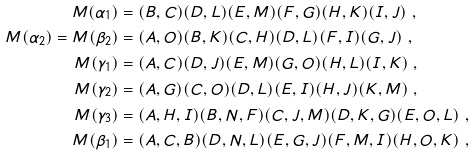Convert formula to latex. <formula><loc_0><loc_0><loc_500><loc_500>M ( \alpha _ { 1 } ) & = ( B , C ) ( D , L ) ( E , M ) ( F , G ) ( H , K ) ( I , J ) \ , \\ M ( \alpha _ { 2 } ) = M ( \beta _ { 2 } ) & = ( A , O ) ( B , K ) ( C , H ) ( D , L ) ( F , I ) ( G , J ) \ , \\ M ( \gamma _ { 1 } ) & = ( A , C ) ( D , J ) ( E , M ) ( G , O ) ( H , L ) ( I , K ) \ , \\ M ( \gamma _ { 2 } ) & = ( A , G ) ( C , O ) ( D , L ) ( E , I ) ( H , J ) ( K , M ) \ , \\ M ( \gamma _ { 3 } ) & = ( A , H , I ) ( B , N , F ) ( C , J , M ) ( D , K , G ) ( E , O , L ) \ , \\ M ( \beta _ { 1 } ) & = ( A , C , B ) ( D , N , L ) ( E , G , J ) ( F , M , I ) ( H , O , K ) \ ,</formula> 